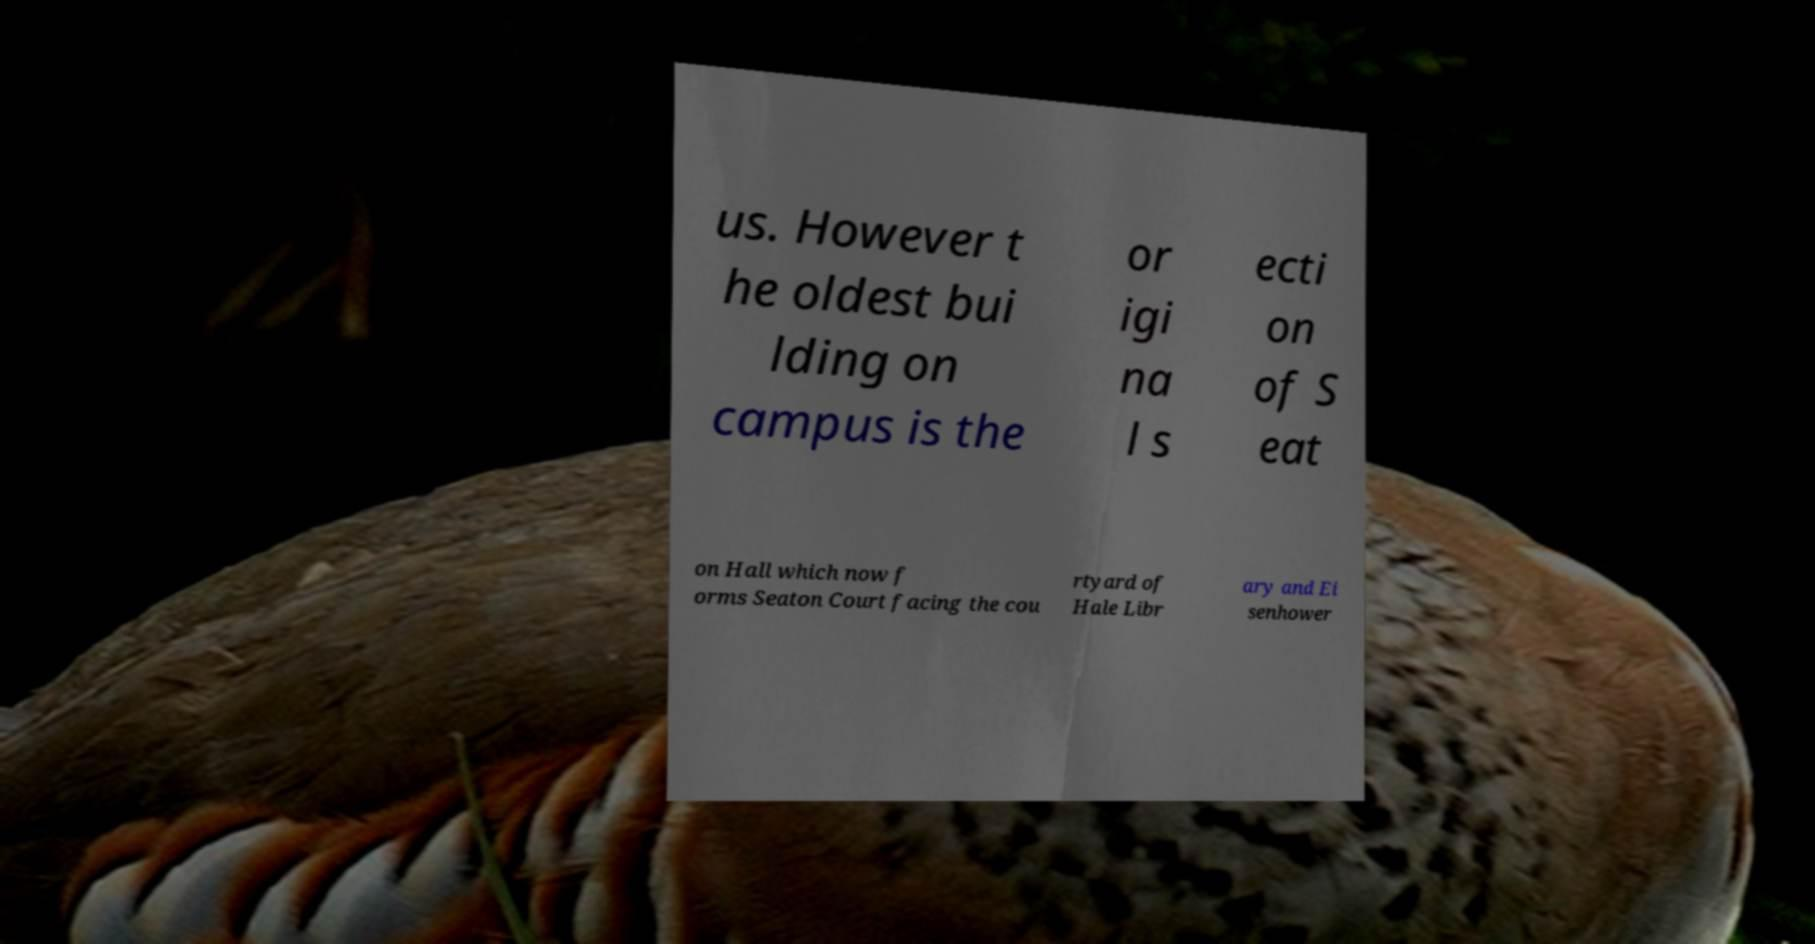Could you extract and type out the text from this image? us. However t he oldest bui lding on campus is the or igi na l s ecti on of S eat on Hall which now f orms Seaton Court facing the cou rtyard of Hale Libr ary and Ei senhower 